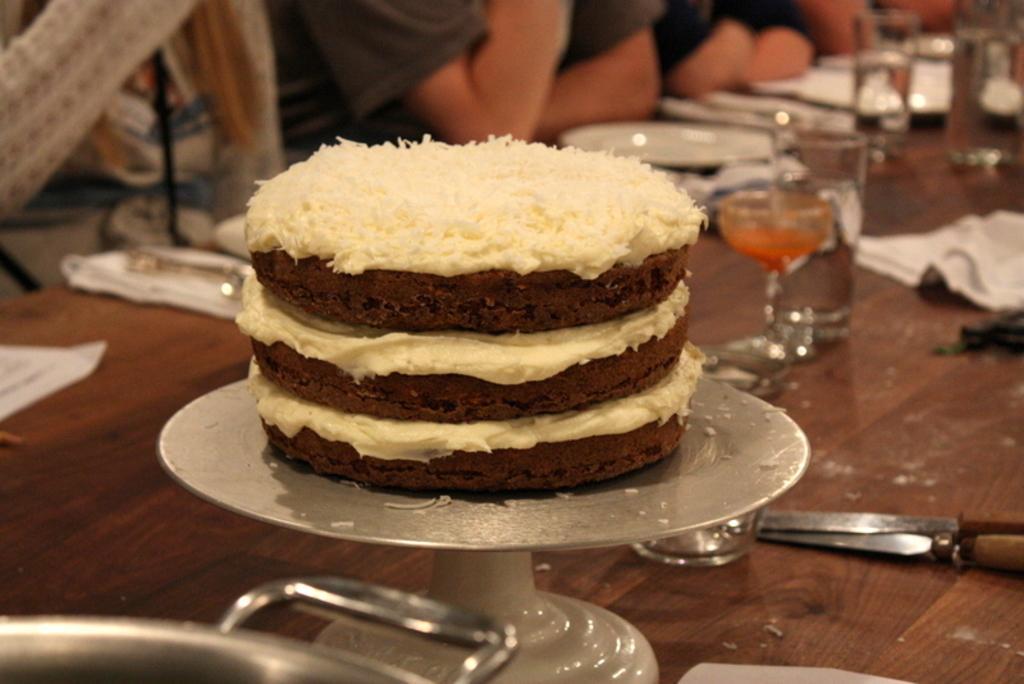Describe this image in one or two sentences. In this image, there is a brown color table, on that table there are some glasses and there are some plates, there is a food item kept on the table, there are some people sitting on the chairs around the table. 